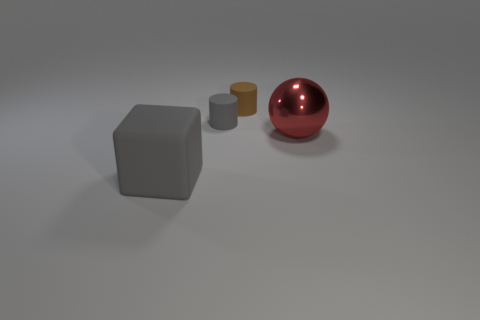Does the brown object have the same shape as the small gray object? yes 